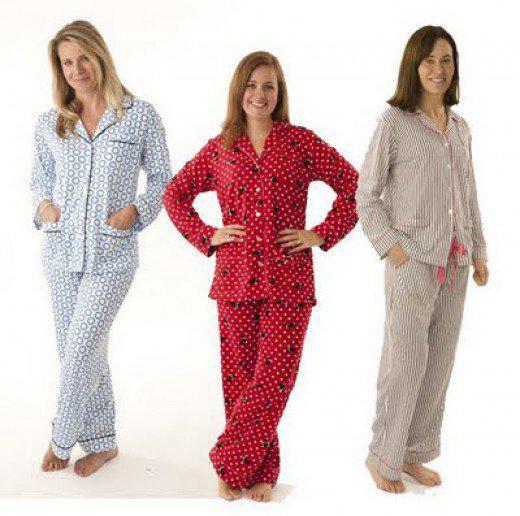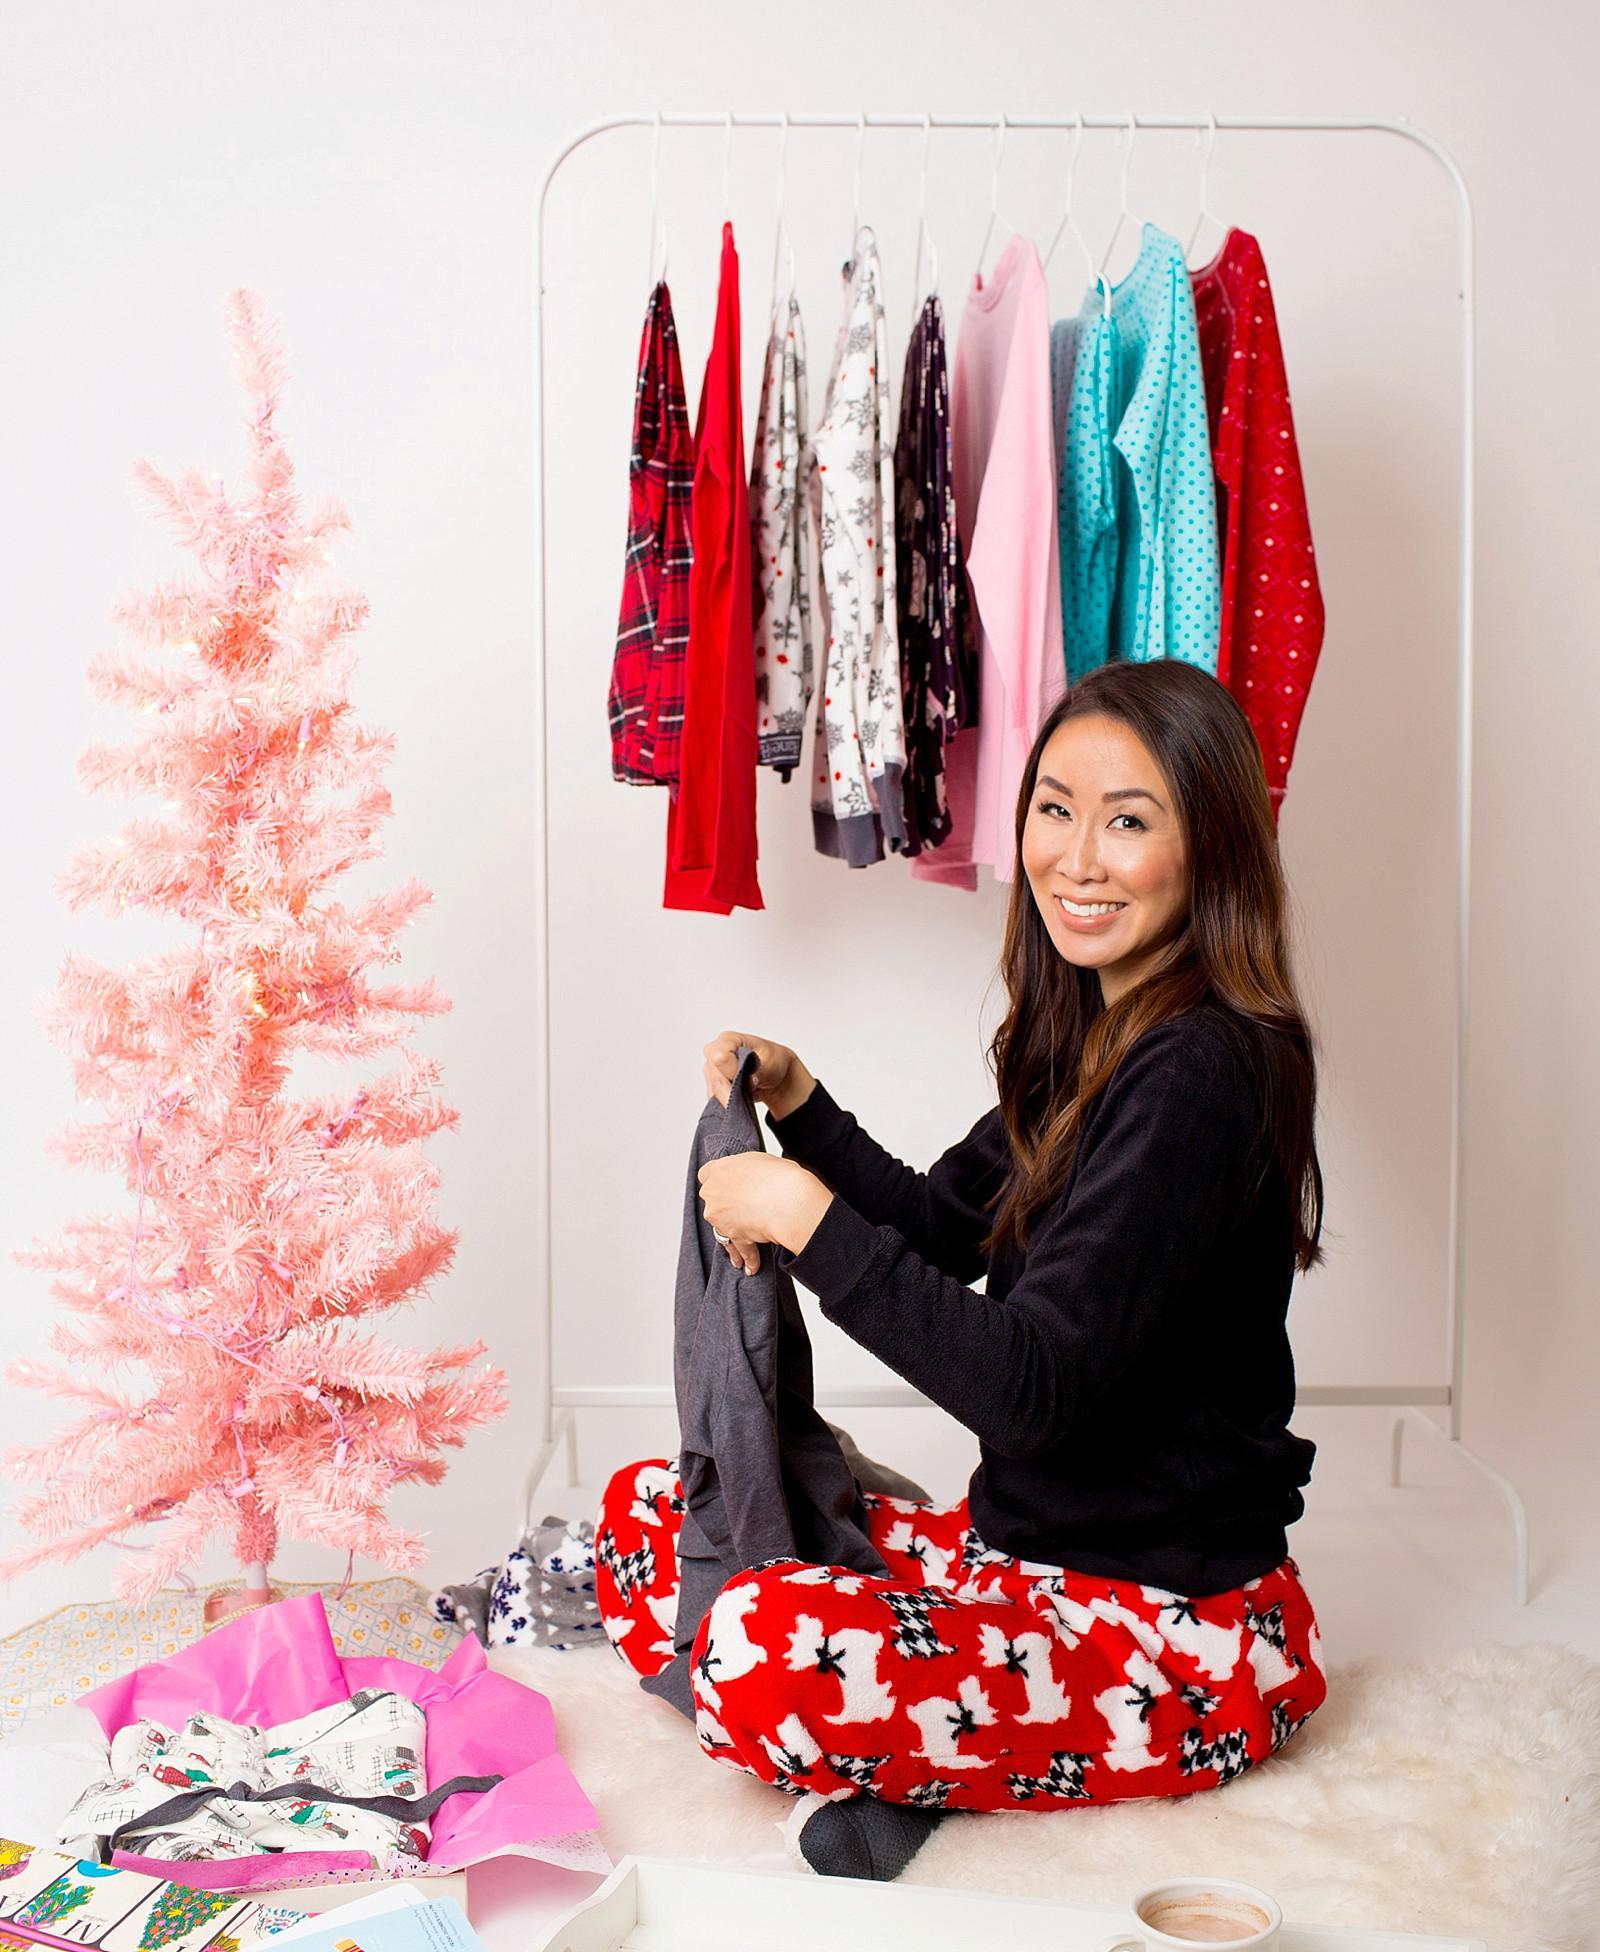The first image is the image on the left, the second image is the image on the right. Analyze the images presented: Is the assertion "An image shows a woman in printed pj pants sitting in front of a small pink Christmas tree." valid? Answer yes or no. Yes. 